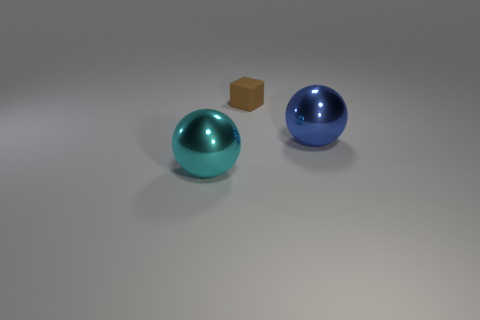What materials do the objects in the image appear to be made of? The objects in the image seem to be fashioned from different materials. The two spheres exhibit a glossy finish indicative of a smooth, reflective metal or perhaps a polished plastic, with the left sphere sporting a cyan tone and the right sphere boasting a deep blue hue. The small cube, situated behind the cyan sphere, possesses a matte finish akin to that of untreated or varnished wood. 